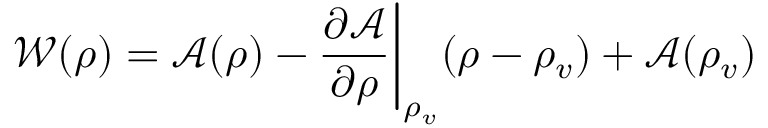<formula> <loc_0><loc_0><loc_500><loc_500>\mathcal { W } ( \rho ) = \mathcal { A } ( \rho ) - \frac { \partial \mathcal { A } } { \partial \rho } \Big | _ { \rho _ { v } } ( \rho - \rho _ { v } ) + \mathcal { A } ( \rho _ { v } )</formula> 